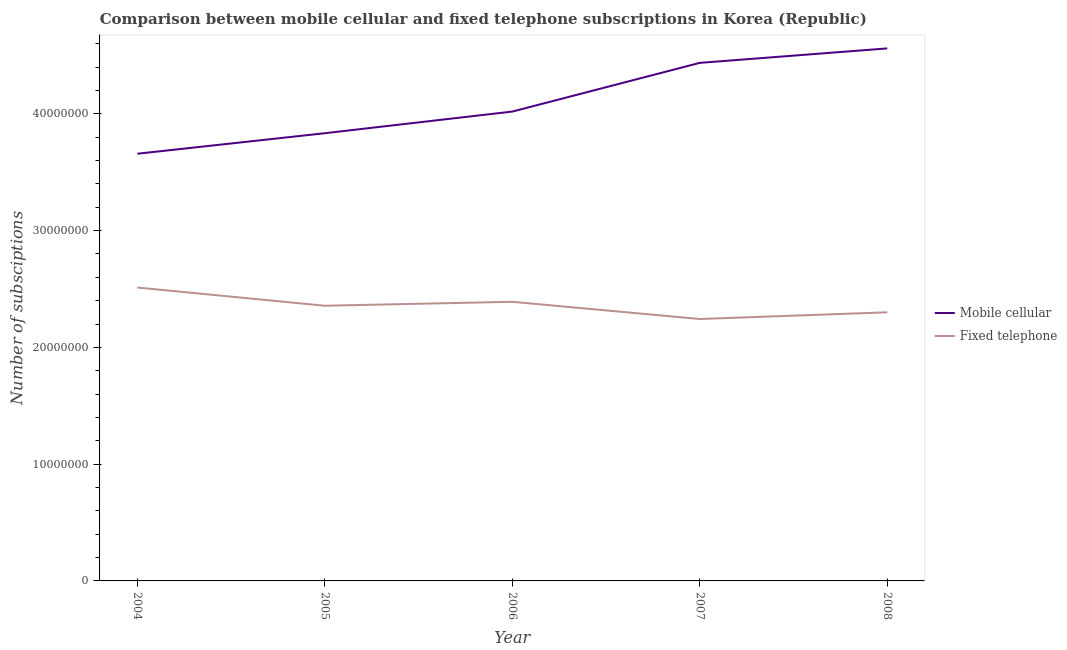How many different coloured lines are there?
Your answer should be very brief. 2. Does the line corresponding to number of fixed telephone subscriptions intersect with the line corresponding to number of mobile cellular subscriptions?
Offer a terse response. No. Is the number of lines equal to the number of legend labels?
Your answer should be compact. Yes. What is the number of fixed telephone subscriptions in 2007?
Give a very brief answer. 2.24e+07. Across all years, what is the maximum number of mobile cellular subscriptions?
Provide a succinct answer. 4.56e+07. Across all years, what is the minimum number of fixed telephone subscriptions?
Offer a very short reply. 2.24e+07. What is the total number of fixed telephone subscriptions in the graph?
Make the answer very short. 1.18e+08. What is the difference between the number of fixed telephone subscriptions in 2005 and that in 2007?
Your response must be concise. 1.14e+06. What is the difference between the number of fixed telephone subscriptions in 2007 and the number of mobile cellular subscriptions in 2005?
Make the answer very short. -1.59e+07. What is the average number of fixed telephone subscriptions per year?
Your answer should be compact. 2.36e+07. In the year 2008, what is the difference between the number of fixed telephone subscriptions and number of mobile cellular subscriptions?
Keep it short and to the point. -2.26e+07. What is the ratio of the number of fixed telephone subscriptions in 2005 to that in 2007?
Give a very brief answer. 1.05. Is the difference between the number of fixed telephone subscriptions in 2006 and 2007 greater than the difference between the number of mobile cellular subscriptions in 2006 and 2007?
Offer a terse response. Yes. What is the difference between the highest and the second highest number of mobile cellular subscriptions?
Keep it short and to the point. 1.24e+06. What is the difference between the highest and the lowest number of mobile cellular subscriptions?
Give a very brief answer. 9.02e+06. In how many years, is the number of mobile cellular subscriptions greater than the average number of mobile cellular subscriptions taken over all years?
Keep it short and to the point. 2. Is the sum of the number of mobile cellular subscriptions in 2006 and 2007 greater than the maximum number of fixed telephone subscriptions across all years?
Your answer should be compact. Yes. Is the number of fixed telephone subscriptions strictly greater than the number of mobile cellular subscriptions over the years?
Your response must be concise. No. How many years are there in the graph?
Keep it short and to the point. 5. What is the difference between two consecutive major ticks on the Y-axis?
Give a very brief answer. 1.00e+07. Does the graph contain any zero values?
Offer a terse response. No. Where does the legend appear in the graph?
Your answer should be compact. Center right. How are the legend labels stacked?
Offer a terse response. Vertical. What is the title of the graph?
Keep it short and to the point. Comparison between mobile cellular and fixed telephone subscriptions in Korea (Republic). Does "Male entrants" appear as one of the legend labels in the graph?
Give a very brief answer. No. What is the label or title of the X-axis?
Make the answer very short. Year. What is the label or title of the Y-axis?
Provide a succinct answer. Number of subsciptions. What is the Number of subsciptions of Mobile cellular in 2004?
Make the answer very short. 3.66e+07. What is the Number of subsciptions in Fixed telephone in 2004?
Give a very brief answer. 2.51e+07. What is the Number of subsciptions in Mobile cellular in 2005?
Make the answer very short. 3.83e+07. What is the Number of subsciptions of Fixed telephone in 2005?
Your answer should be very brief. 2.36e+07. What is the Number of subsciptions of Mobile cellular in 2006?
Keep it short and to the point. 4.02e+07. What is the Number of subsciptions in Fixed telephone in 2006?
Offer a terse response. 2.39e+07. What is the Number of subsciptions of Mobile cellular in 2007?
Give a very brief answer. 4.44e+07. What is the Number of subsciptions in Fixed telephone in 2007?
Provide a short and direct response. 2.24e+07. What is the Number of subsciptions of Mobile cellular in 2008?
Ensure brevity in your answer.  4.56e+07. What is the Number of subsciptions in Fixed telephone in 2008?
Your answer should be compact. 2.30e+07. Across all years, what is the maximum Number of subsciptions of Mobile cellular?
Make the answer very short. 4.56e+07. Across all years, what is the maximum Number of subsciptions of Fixed telephone?
Offer a terse response. 2.51e+07. Across all years, what is the minimum Number of subsciptions in Mobile cellular?
Your answer should be compact. 3.66e+07. Across all years, what is the minimum Number of subsciptions in Fixed telephone?
Offer a terse response. 2.24e+07. What is the total Number of subsciptions of Mobile cellular in the graph?
Your response must be concise. 2.05e+08. What is the total Number of subsciptions of Fixed telephone in the graph?
Provide a short and direct response. 1.18e+08. What is the difference between the Number of subsciptions in Mobile cellular in 2004 and that in 2005?
Keep it short and to the point. -1.76e+06. What is the difference between the Number of subsciptions in Fixed telephone in 2004 and that in 2005?
Keep it short and to the point. 1.56e+06. What is the difference between the Number of subsciptions in Mobile cellular in 2004 and that in 2006?
Your response must be concise. -3.61e+06. What is the difference between the Number of subsciptions in Fixed telephone in 2004 and that in 2006?
Your response must be concise. 1.22e+06. What is the difference between the Number of subsciptions of Mobile cellular in 2004 and that in 2007?
Your answer should be compact. -7.78e+06. What is the difference between the Number of subsciptions of Fixed telephone in 2004 and that in 2007?
Provide a short and direct response. 2.70e+06. What is the difference between the Number of subsciptions in Mobile cellular in 2004 and that in 2008?
Your answer should be very brief. -9.02e+06. What is the difference between the Number of subsciptions in Fixed telephone in 2004 and that in 2008?
Your answer should be very brief. 2.12e+06. What is the difference between the Number of subsciptions of Mobile cellular in 2005 and that in 2006?
Provide a succinct answer. -1.85e+06. What is the difference between the Number of subsciptions of Fixed telephone in 2005 and that in 2006?
Your response must be concise. -3.37e+05. What is the difference between the Number of subsciptions of Mobile cellular in 2005 and that in 2007?
Make the answer very short. -6.03e+06. What is the difference between the Number of subsciptions of Fixed telephone in 2005 and that in 2007?
Provide a short and direct response. 1.14e+06. What is the difference between the Number of subsciptions in Mobile cellular in 2005 and that in 2008?
Offer a very short reply. -7.26e+06. What is the difference between the Number of subsciptions in Fixed telephone in 2005 and that in 2008?
Offer a terse response. 5.61e+05. What is the difference between the Number of subsciptions of Mobile cellular in 2006 and that in 2007?
Keep it short and to the point. -4.17e+06. What is the difference between the Number of subsciptions in Fixed telephone in 2006 and that in 2007?
Your answer should be very brief. 1.47e+06. What is the difference between the Number of subsciptions of Mobile cellular in 2006 and that in 2008?
Give a very brief answer. -5.41e+06. What is the difference between the Number of subsciptions of Fixed telephone in 2006 and that in 2008?
Provide a short and direct response. 8.98e+05. What is the difference between the Number of subsciptions in Mobile cellular in 2007 and that in 2008?
Ensure brevity in your answer.  -1.24e+06. What is the difference between the Number of subsciptions of Fixed telephone in 2007 and that in 2008?
Provide a succinct answer. -5.75e+05. What is the difference between the Number of subsciptions of Mobile cellular in 2004 and the Number of subsciptions of Fixed telephone in 2005?
Your answer should be very brief. 1.30e+07. What is the difference between the Number of subsciptions in Mobile cellular in 2004 and the Number of subsciptions in Fixed telephone in 2006?
Make the answer very short. 1.27e+07. What is the difference between the Number of subsciptions of Mobile cellular in 2004 and the Number of subsciptions of Fixed telephone in 2007?
Offer a very short reply. 1.42e+07. What is the difference between the Number of subsciptions of Mobile cellular in 2004 and the Number of subsciptions of Fixed telephone in 2008?
Offer a very short reply. 1.36e+07. What is the difference between the Number of subsciptions of Mobile cellular in 2005 and the Number of subsciptions of Fixed telephone in 2006?
Provide a succinct answer. 1.44e+07. What is the difference between the Number of subsciptions in Mobile cellular in 2005 and the Number of subsciptions in Fixed telephone in 2007?
Keep it short and to the point. 1.59e+07. What is the difference between the Number of subsciptions of Mobile cellular in 2005 and the Number of subsciptions of Fixed telephone in 2008?
Your response must be concise. 1.53e+07. What is the difference between the Number of subsciptions of Mobile cellular in 2006 and the Number of subsciptions of Fixed telephone in 2007?
Make the answer very short. 1.78e+07. What is the difference between the Number of subsciptions of Mobile cellular in 2006 and the Number of subsciptions of Fixed telephone in 2008?
Keep it short and to the point. 1.72e+07. What is the difference between the Number of subsciptions in Mobile cellular in 2007 and the Number of subsciptions in Fixed telephone in 2008?
Offer a very short reply. 2.14e+07. What is the average Number of subsciptions in Mobile cellular per year?
Provide a succinct answer. 4.10e+07. What is the average Number of subsciptions in Fixed telephone per year?
Your answer should be compact. 2.36e+07. In the year 2004, what is the difference between the Number of subsciptions in Mobile cellular and Number of subsciptions in Fixed telephone?
Your answer should be compact. 1.15e+07. In the year 2005, what is the difference between the Number of subsciptions of Mobile cellular and Number of subsciptions of Fixed telephone?
Provide a short and direct response. 1.48e+07. In the year 2006, what is the difference between the Number of subsciptions of Mobile cellular and Number of subsciptions of Fixed telephone?
Provide a succinct answer. 1.63e+07. In the year 2007, what is the difference between the Number of subsciptions in Mobile cellular and Number of subsciptions in Fixed telephone?
Ensure brevity in your answer.  2.19e+07. In the year 2008, what is the difference between the Number of subsciptions in Mobile cellular and Number of subsciptions in Fixed telephone?
Your answer should be compact. 2.26e+07. What is the ratio of the Number of subsciptions of Mobile cellular in 2004 to that in 2005?
Keep it short and to the point. 0.95. What is the ratio of the Number of subsciptions of Fixed telephone in 2004 to that in 2005?
Give a very brief answer. 1.07. What is the ratio of the Number of subsciptions in Mobile cellular in 2004 to that in 2006?
Your response must be concise. 0.91. What is the ratio of the Number of subsciptions in Fixed telephone in 2004 to that in 2006?
Offer a terse response. 1.05. What is the ratio of the Number of subsciptions of Mobile cellular in 2004 to that in 2007?
Offer a terse response. 0.82. What is the ratio of the Number of subsciptions of Fixed telephone in 2004 to that in 2007?
Your response must be concise. 1.12. What is the ratio of the Number of subsciptions in Mobile cellular in 2004 to that in 2008?
Provide a succinct answer. 0.8. What is the ratio of the Number of subsciptions in Fixed telephone in 2004 to that in 2008?
Your answer should be very brief. 1.09. What is the ratio of the Number of subsciptions in Mobile cellular in 2005 to that in 2006?
Provide a succinct answer. 0.95. What is the ratio of the Number of subsciptions in Fixed telephone in 2005 to that in 2006?
Provide a succinct answer. 0.99. What is the ratio of the Number of subsciptions in Mobile cellular in 2005 to that in 2007?
Ensure brevity in your answer.  0.86. What is the ratio of the Number of subsciptions of Fixed telephone in 2005 to that in 2007?
Provide a short and direct response. 1.05. What is the ratio of the Number of subsciptions of Mobile cellular in 2005 to that in 2008?
Ensure brevity in your answer.  0.84. What is the ratio of the Number of subsciptions in Fixed telephone in 2005 to that in 2008?
Offer a terse response. 1.02. What is the ratio of the Number of subsciptions in Mobile cellular in 2006 to that in 2007?
Provide a short and direct response. 0.91. What is the ratio of the Number of subsciptions of Fixed telephone in 2006 to that in 2007?
Give a very brief answer. 1.07. What is the ratio of the Number of subsciptions in Mobile cellular in 2006 to that in 2008?
Your answer should be compact. 0.88. What is the ratio of the Number of subsciptions in Fixed telephone in 2006 to that in 2008?
Offer a very short reply. 1.04. What is the ratio of the Number of subsciptions in Mobile cellular in 2007 to that in 2008?
Your response must be concise. 0.97. What is the ratio of the Number of subsciptions of Fixed telephone in 2007 to that in 2008?
Your response must be concise. 0.97. What is the difference between the highest and the second highest Number of subsciptions of Mobile cellular?
Provide a succinct answer. 1.24e+06. What is the difference between the highest and the second highest Number of subsciptions in Fixed telephone?
Provide a short and direct response. 1.22e+06. What is the difference between the highest and the lowest Number of subsciptions of Mobile cellular?
Your answer should be very brief. 9.02e+06. What is the difference between the highest and the lowest Number of subsciptions of Fixed telephone?
Your answer should be compact. 2.70e+06. 